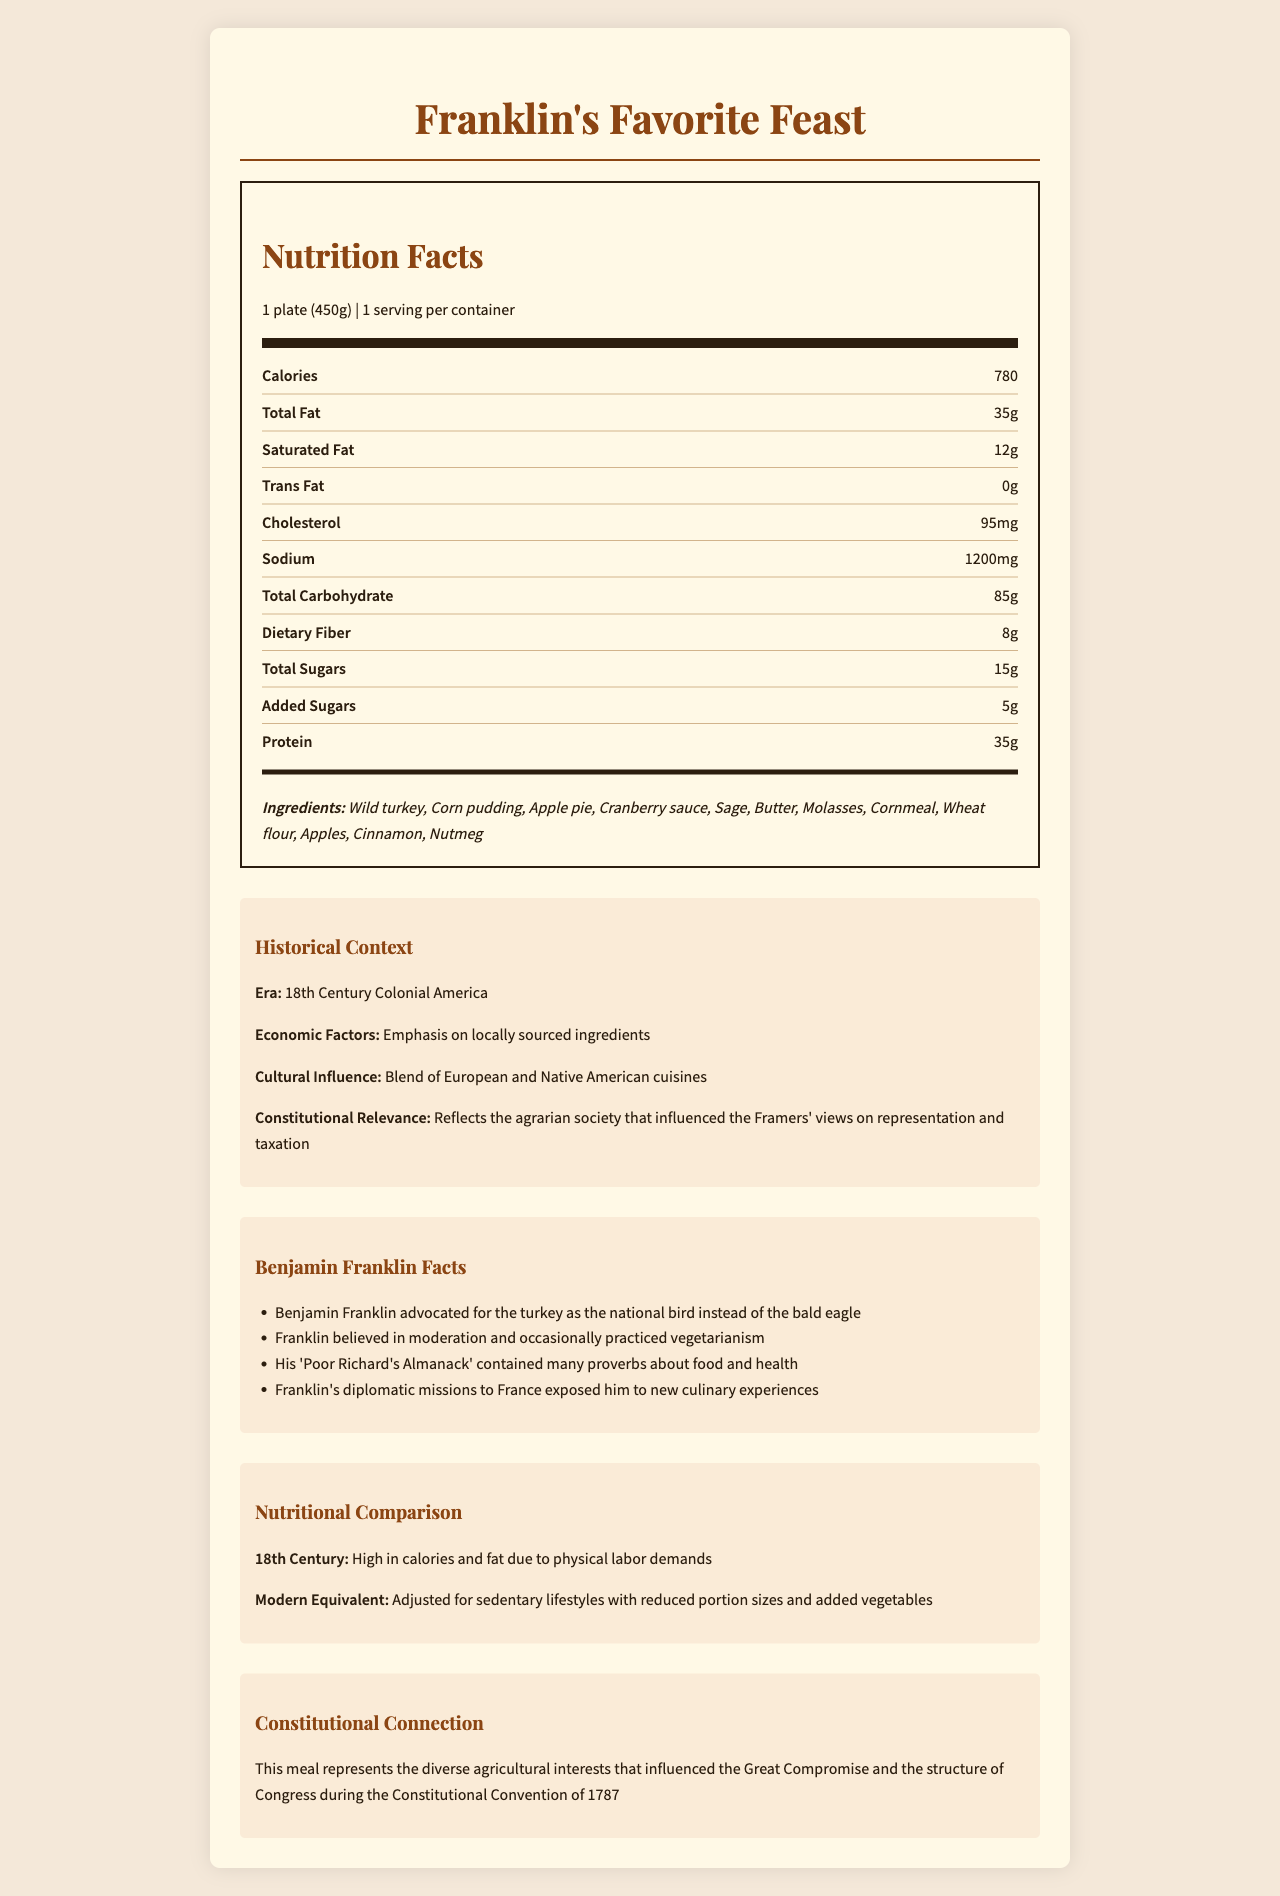What is the serving size of Franklin's Favorite Feast? The serving size is stated just below the section title "Nutrition Facts" as "1 plate (450g)".
Answer: 1 plate (450g) How many calories are in a single serving of Franklin's Favorite Feast? The number of calories per serving is listed as 780 under the "Calories" section in the nutrition facts.
Answer: 780 What is the total fat content in one serving? The total fat content is specified as 35g in the nutrition facts label.
Answer: 35g Which ingredient in Franklin's Favorite Feast might Benjamin Franklin have advocated as the national bird? The historical context mentions that Benjamin Franklin advocated for the turkey as the national bird instead of the bald eagle, and wild turkey is listed as an ingredient.
Answer: Wild turkey How much protein does one serving provide? The protein content for one serving is listed as 35g in the nutrition facts.
Answer: 35g Which of the following ingredients is NOT listed in Franklin's Favorite Feast? A. Wild turkey B. Sage C. Nutmeg D. Honey The ingredients list includes Wild turkey, Sage, Nutmeg, but not Honey.
Answer: D. Honey What era does Franklin's Favorite Feast belong to according to the historical context? A. 19th Century America B. 18th Century Colonial America C. 17th Century England D. Early Modern Europe The historical context specifies the era as "18th Century Colonial America".
Answer: B. 18th Century Colonial America True or False: The meal has zero trans fat. The nutrition facts list trans fat content as 0g, indicating it has zero trans fat.
Answer: True Summarize the main idea of the document. The document provides an overview of "Franklin's Favorite Feast," detailing nutritional facts, historical and cultural background, Benjamin Franklin's food-related interests, and the connection to the agrarian roots of the U.S. Constitution.
Answer: Franklin's Favorite Feast is a modern interpretation of Benjamin Franklin's favorite foods, framed within the historical and nutritional context of 18th Century Colonial America. It includes nutritional information, historical context about the dish's origins, Franklin's food-related preferences, and its connection to the U.S. Constitution. How does the document describe the economic factors influencing the ingredients of Franklin's Favorite Feast? The historical context section mentions that economic factors during the era emphasized locally sourced ingredients.
Answer: Emphasis on locally sourced ingredients In what way does the document relate Franklin's Favorite Feast to the U.S. Constitution? The document connects the meal to the Constitution by highlighting its representation of the diverse agricultural interests that influenced the Great Compromise and the structure of Congress.
Answer: Reflects the diverse agricultural interests that influenced the Great Compromise and the structure of Congress during the Constitutional Convention of 1787 How many grams of saturated fat are in a serving of Franklin's Favorite Feast? The nutrition facts state that there are 12 grams of saturated fat per serving.
Answer: 12 Which fruit is used in Franklin's Favorite Feast? A. Bananas B. Apples C. Peaches D. Grapes The ingredients list includes Apples, Corn pudding, and Apple pie, but not Bananas, Peaches, or Grapes.
Answer: B. Apples How much dietary fiber is in one serving? The dietary fiber content in one serving is 8g, as listed in the nutrition facts.
Answer: 8g What other culinary experiences influenced Benjamin Franklin's taste according to the document? The Franklin facts section mentions that Franklin's diplomatic missions to France exposed him to new culinary experiences.
Answer: Diplomatic missions to France What is the difference in nutritional needs between the 18th century and modern times as mentioned in the document? The nutritional comparison section states that the 18th century diet was high in calories and fat due to physical labor demands, whereas the modern equivalent is adjusted for sedentary lifestyles with reduced portion sizes and added vegetables.
Answer: High in calories and fat due to physical labor demands; adjusted for sedentary lifestyles with reduced portion sizes and added vegetables What are the added sugars content in one serving? The nutrition facts state that there are 5 grams of added sugars per serving.
Answer: 5g What other work by Benjamin Franklin is mentioned in the document? The document mentions that his "Poor Richard's Almanack" contained many proverbs about food and health.
Answer: Poor Richard's Almanack Why did Franklin practice vegetarianism according to the document? The document mentions that Franklin occasionally practiced vegetarianism but does not provide enough information on why he did so.
Answer: Not enough information 